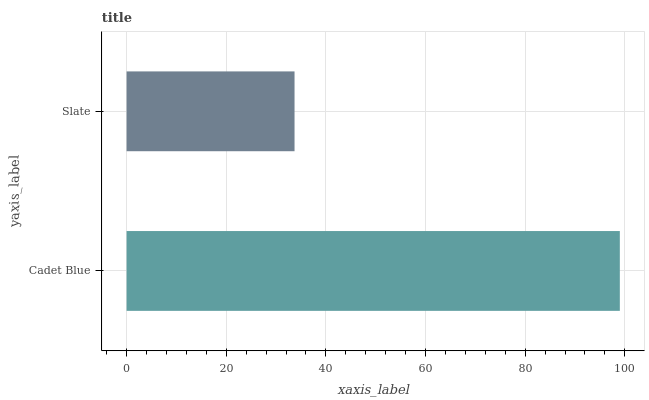Is Slate the minimum?
Answer yes or no. Yes. Is Cadet Blue the maximum?
Answer yes or no. Yes. Is Slate the maximum?
Answer yes or no. No. Is Cadet Blue greater than Slate?
Answer yes or no. Yes. Is Slate less than Cadet Blue?
Answer yes or no. Yes. Is Slate greater than Cadet Blue?
Answer yes or no. No. Is Cadet Blue less than Slate?
Answer yes or no. No. Is Cadet Blue the high median?
Answer yes or no. Yes. Is Slate the low median?
Answer yes or no. Yes. Is Slate the high median?
Answer yes or no. No. Is Cadet Blue the low median?
Answer yes or no. No. 